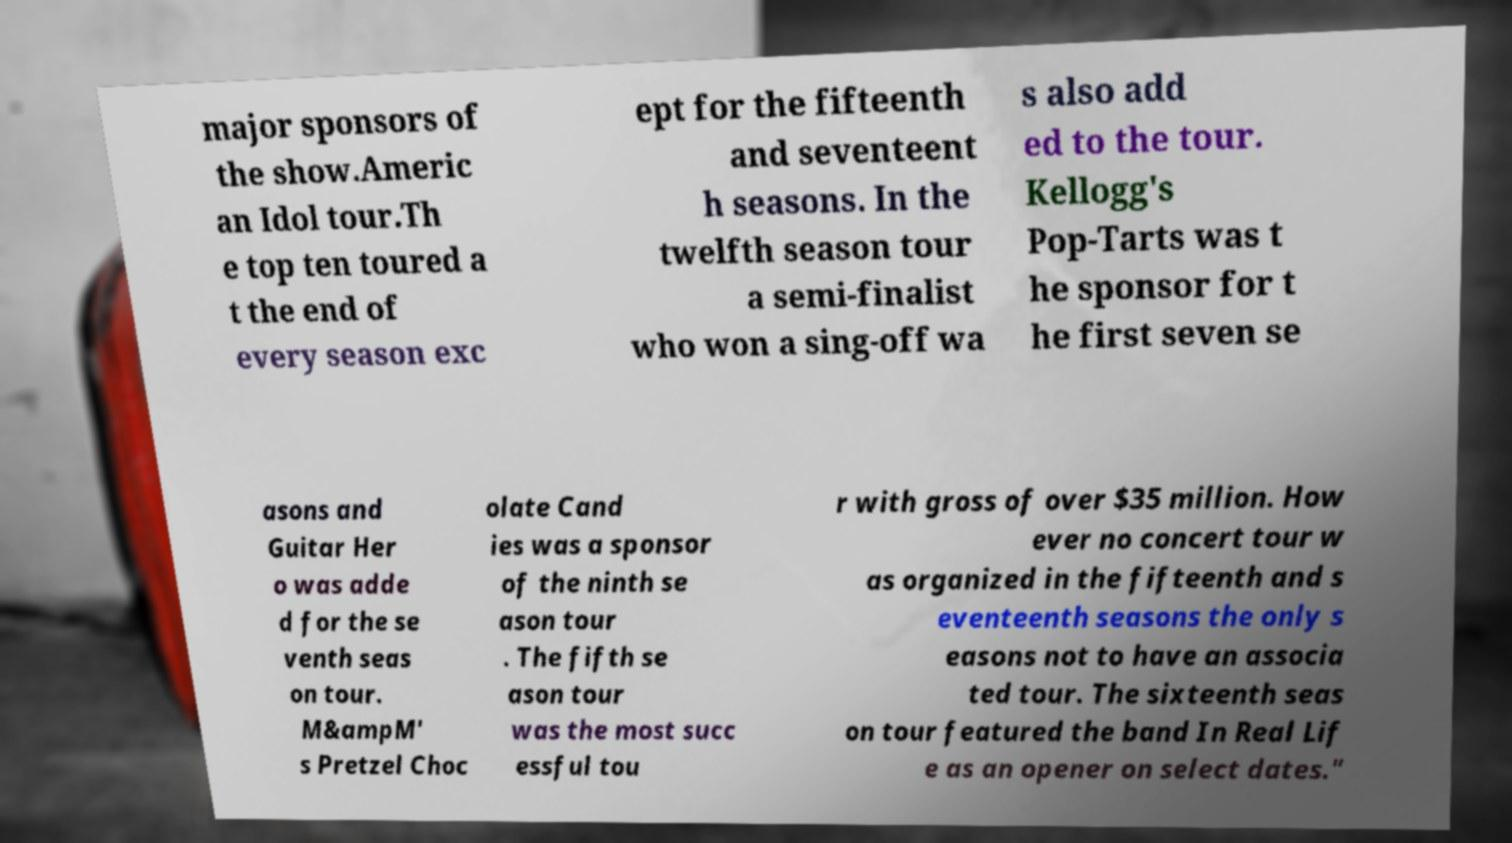I need the written content from this picture converted into text. Can you do that? major sponsors of the show.Americ an Idol tour.Th e top ten toured a t the end of every season exc ept for the fifteenth and seventeent h seasons. In the twelfth season tour a semi-finalist who won a sing-off wa s also add ed to the tour. Kellogg's Pop-Tarts was t he sponsor for t he first seven se asons and Guitar Her o was adde d for the se venth seas on tour. M&ampM' s Pretzel Choc olate Cand ies was a sponsor of the ninth se ason tour . The fifth se ason tour was the most succ essful tou r with gross of over $35 million. How ever no concert tour w as organized in the fifteenth and s eventeenth seasons the only s easons not to have an associa ted tour. The sixteenth seas on tour featured the band In Real Lif e as an opener on select dates." 